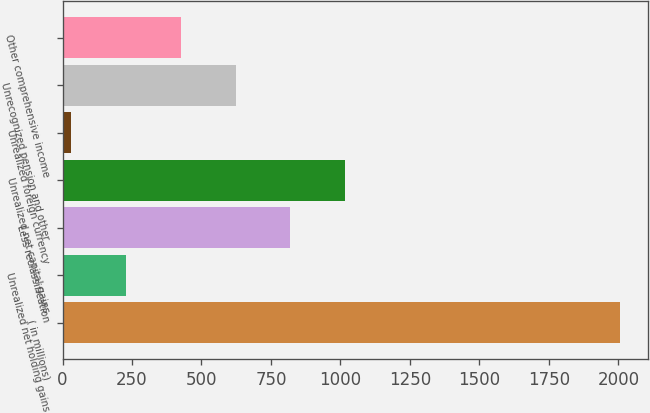<chart> <loc_0><loc_0><loc_500><loc_500><bar_chart><fcel>( in millions)<fcel>Unrealized net holding gains<fcel>Less reclassification<fcel>Unrealized net capital gains<fcel>Unrealized foreign currency<fcel>Unrecognized pension and other<fcel>Other comprehensive income<nl><fcel>2007<fcel>226.8<fcel>820.2<fcel>1018<fcel>29<fcel>622.4<fcel>424.6<nl></chart> 